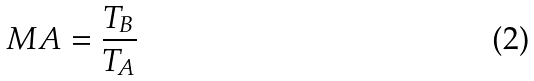<formula> <loc_0><loc_0><loc_500><loc_500>M A = \frac { T _ { B } } { T _ { A } }</formula> 